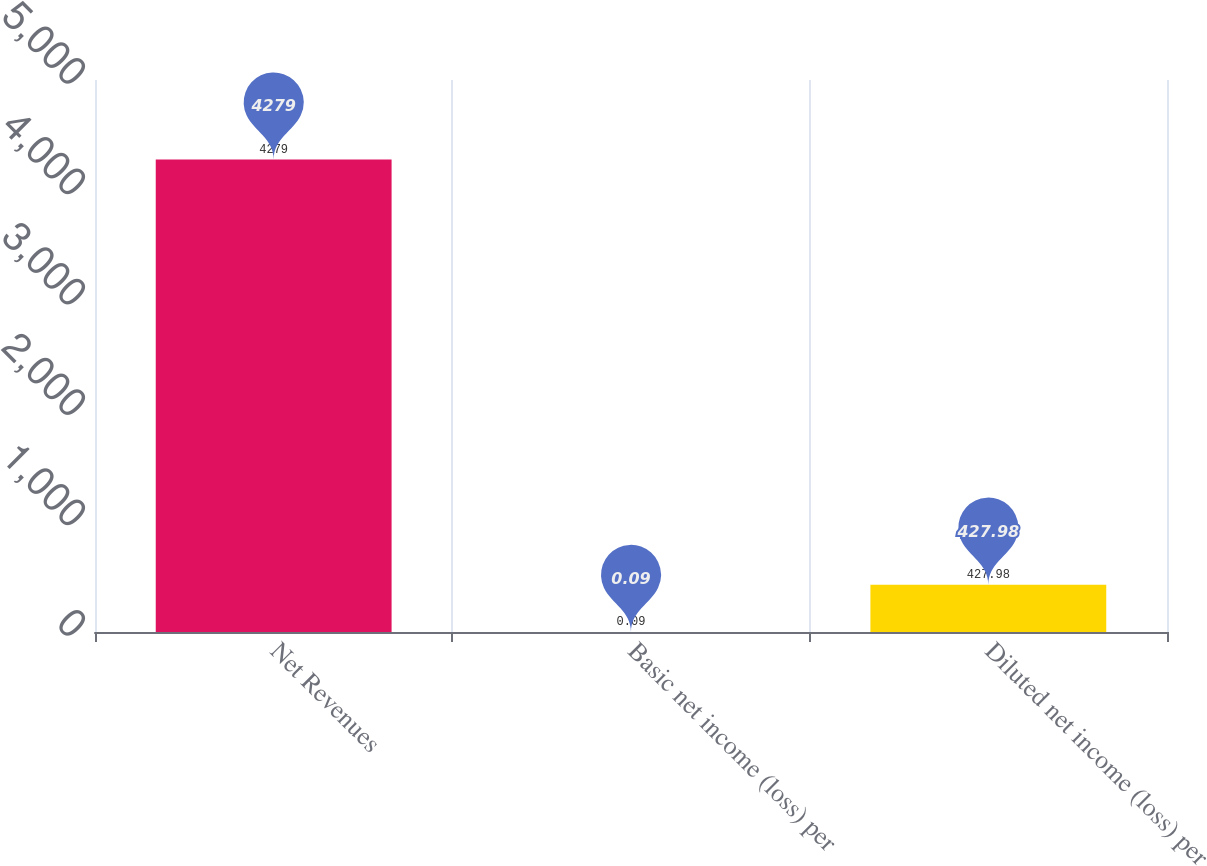Convert chart to OTSL. <chart><loc_0><loc_0><loc_500><loc_500><bar_chart><fcel>Net Revenues<fcel>Basic net income (loss) per<fcel>Diluted net income (loss) per<nl><fcel>4279<fcel>0.09<fcel>427.98<nl></chart> 